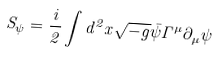<formula> <loc_0><loc_0><loc_500><loc_500>S _ { \psi } = \frac { i } { 2 } \int d ^ { 2 } x \sqrt { - g } \bar { \psi } \Gamma ^ { \mu } \partial _ { \mu } \psi</formula> 